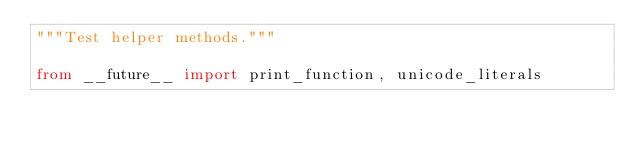Convert code to text. <code><loc_0><loc_0><loc_500><loc_500><_Python_>"""Test helper methods."""

from __future__ import print_function, unicode_literals
</code> 